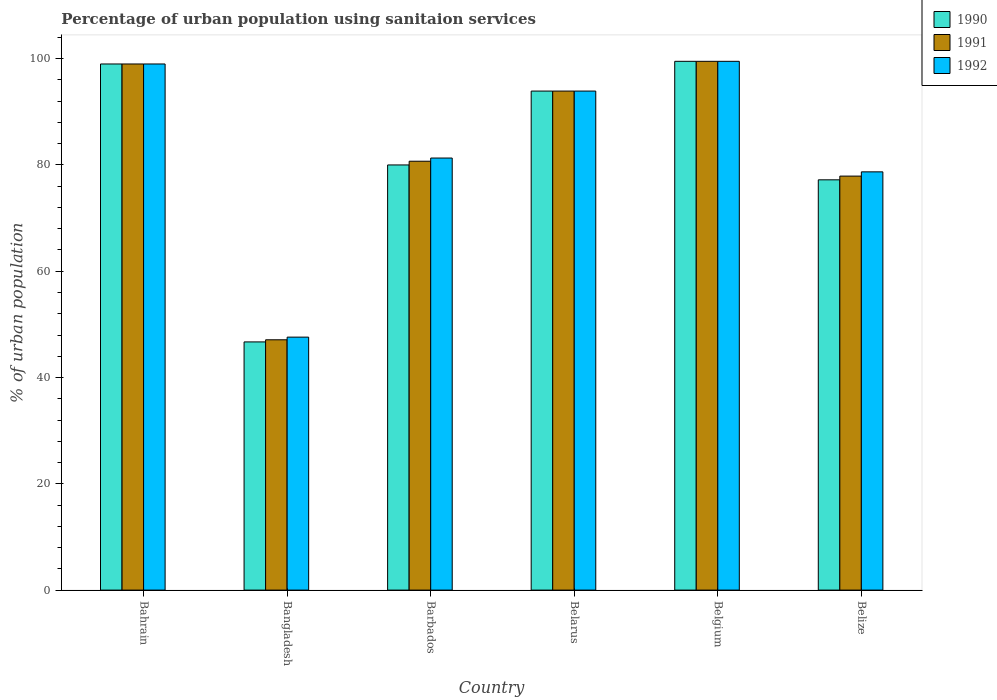How many different coloured bars are there?
Your response must be concise. 3. How many groups of bars are there?
Make the answer very short. 6. How many bars are there on the 6th tick from the right?
Your answer should be compact. 3. In how many cases, is the number of bars for a given country not equal to the number of legend labels?
Offer a very short reply. 0. What is the percentage of urban population using sanitaion services in 1990 in Belarus?
Keep it short and to the point. 93.9. Across all countries, what is the maximum percentage of urban population using sanitaion services in 1990?
Offer a very short reply. 99.5. Across all countries, what is the minimum percentage of urban population using sanitaion services in 1992?
Your response must be concise. 47.6. What is the total percentage of urban population using sanitaion services in 1991 in the graph?
Provide a short and direct response. 498.1. What is the difference between the percentage of urban population using sanitaion services in 1990 in Bahrain and that in Bangladesh?
Make the answer very short. 52.3. What is the difference between the percentage of urban population using sanitaion services in 1991 in Bangladesh and the percentage of urban population using sanitaion services in 1990 in Bahrain?
Provide a short and direct response. -51.9. What is the average percentage of urban population using sanitaion services in 1990 per country?
Offer a terse response. 82.72. What is the difference between the percentage of urban population using sanitaion services of/in 1990 and percentage of urban population using sanitaion services of/in 1991 in Bahrain?
Offer a terse response. 0. What is the ratio of the percentage of urban population using sanitaion services in 1992 in Bangladesh to that in Barbados?
Offer a very short reply. 0.59. Is the difference between the percentage of urban population using sanitaion services in 1990 in Belarus and Belgium greater than the difference between the percentage of urban population using sanitaion services in 1991 in Belarus and Belgium?
Offer a very short reply. No. What is the difference between the highest and the second highest percentage of urban population using sanitaion services in 1992?
Keep it short and to the point. -0.5. What is the difference between the highest and the lowest percentage of urban population using sanitaion services in 1990?
Make the answer very short. 52.8. Is the sum of the percentage of urban population using sanitaion services in 1991 in Barbados and Belarus greater than the maximum percentage of urban population using sanitaion services in 1990 across all countries?
Make the answer very short. Yes. What does the 3rd bar from the left in Belize represents?
Give a very brief answer. 1992. Is it the case that in every country, the sum of the percentage of urban population using sanitaion services in 1991 and percentage of urban population using sanitaion services in 1990 is greater than the percentage of urban population using sanitaion services in 1992?
Give a very brief answer. Yes. How many countries are there in the graph?
Offer a terse response. 6. What is the difference between two consecutive major ticks on the Y-axis?
Provide a short and direct response. 20. Are the values on the major ticks of Y-axis written in scientific E-notation?
Keep it short and to the point. No. Does the graph contain grids?
Give a very brief answer. No. How many legend labels are there?
Ensure brevity in your answer.  3. What is the title of the graph?
Provide a succinct answer. Percentage of urban population using sanitaion services. Does "2002" appear as one of the legend labels in the graph?
Keep it short and to the point. No. What is the label or title of the X-axis?
Provide a succinct answer. Country. What is the label or title of the Y-axis?
Offer a very short reply. % of urban population. What is the % of urban population in 1992 in Bahrain?
Your answer should be very brief. 99. What is the % of urban population in 1990 in Bangladesh?
Offer a terse response. 46.7. What is the % of urban population of 1991 in Bangladesh?
Provide a short and direct response. 47.1. What is the % of urban population of 1992 in Bangladesh?
Offer a terse response. 47.6. What is the % of urban population in 1991 in Barbados?
Your answer should be very brief. 80.7. What is the % of urban population in 1992 in Barbados?
Give a very brief answer. 81.3. What is the % of urban population of 1990 in Belarus?
Give a very brief answer. 93.9. What is the % of urban population of 1991 in Belarus?
Your answer should be compact. 93.9. What is the % of urban population of 1992 in Belarus?
Your response must be concise. 93.9. What is the % of urban population of 1990 in Belgium?
Your answer should be very brief. 99.5. What is the % of urban population of 1991 in Belgium?
Ensure brevity in your answer.  99.5. What is the % of urban population in 1992 in Belgium?
Provide a short and direct response. 99.5. What is the % of urban population in 1990 in Belize?
Provide a succinct answer. 77.2. What is the % of urban population of 1991 in Belize?
Your response must be concise. 77.9. What is the % of urban population in 1992 in Belize?
Offer a terse response. 78.7. Across all countries, what is the maximum % of urban population of 1990?
Your answer should be compact. 99.5. Across all countries, what is the maximum % of urban population of 1991?
Your answer should be very brief. 99.5. Across all countries, what is the maximum % of urban population in 1992?
Provide a succinct answer. 99.5. Across all countries, what is the minimum % of urban population in 1990?
Offer a very short reply. 46.7. Across all countries, what is the minimum % of urban population in 1991?
Provide a succinct answer. 47.1. Across all countries, what is the minimum % of urban population of 1992?
Keep it short and to the point. 47.6. What is the total % of urban population in 1990 in the graph?
Offer a terse response. 496.3. What is the total % of urban population of 1991 in the graph?
Provide a succinct answer. 498.1. What is the difference between the % of urban population of 1990 in Bahrain and that in Bangladesh?
Make the answer very short. 52.3. What is the difference between the % of urban population of 1991 in Bahrain and that in Bangladesh?
Make the answer very short. 51.9. What is the difference between the % of urban population in 1992 in Bahrain and that in Bangladesh?
Provide a short and direct response. 51.4. What is the difference between the % of urban population in 1990 in Bahrain and that in Barbados?
Your response must be concise. 19. What is the difference between the % of urban population in 1991 in Bahrain and that in Barbados?
Provide a succinct answer. 18.3. What is the difference between the % of urban population in 1991 in Bahrain and that in Belarus?
Offer a very short reply. 5.1. What is the difference between the % of urban population of 1991 in Bahrain and that in Belgium?
Your response must be concise. -0.5. What is the difference between the % of urban population of 1990 in Bahrain and that in Belize?
Offer a very short reply. 21.8. What is the difference between the % of urban population of 1991 in Bahrain and that in Belize?
Make the answer very short. 21.1. What is the difference between the % of urban population in 1992 in Bahrain and that in Belize?
Give a very brief answer. 20.3. What is the difference between the % of urban population of 1990 in Bangladesh and that in Barbados?
Your answer should be compact. -33.3. What is the difference between the % of urban population of 1991 in Bangladesh and that in Barbados?
Give a very brief answer. -33.6. What is the difference between the % of urban population of 1992 in Bangladesh and that in Barbados?
Your response must be concise. -33.7. What is the difference between the % of urban population in 1990 in Bangladesh and that in Belarus?
Provide a succinct answer. -47.2. What is the difference between the % of urban population of 1991 in Bangladesh and that in Belarus?
Offer a very short reply. -46.8. What is the difference between the % of urban population of 1992 in Bangladesh and that in Belarus?
Your answer should be very brief. -46.3. What is the difference between the % of urban population in 1990 in Bangladesh and that in Belgium?
Your response must be concise. -52.8. What is the difference between the % of urban population of 1991 in Bangladesh and that in Belgium?
Provide a short and direct response. -52.4. What is the difference between the % of urban population in 1992 in Bangladesh and that in Belgium?
Your answer should be compact. -51.9. What is the difference between the % of urban population of 1990 in Bangladesh and that in Belize?
Provide a short and direct response. -30.5. What is the difference between the % of urban population in 1991 in Bangladesh and that in Belize?
Offer a terse response. -30.8. What is the difference between the % of urban population in 1992 in Bangladesh and that in Belize?
Give a very brief answer. -31.1. What is the difference between the % of urban population of 1990 in Barbados and that in Belarus?
Give a very brief answer. -13.9. What is the difference between the % of urban population of 1990 in Barbados and that in Belgium?
Provide a short and direct response. -19.5. What is the difference between the % of urban population in 1991 in Barbados and that in Belgium?
Keep it short and to the point. -18.8. What is the difference between the % of urban population in 1992 in Barbados and that in Belgium?
Your answer should be very brief. -18.2. What is the difference between the % of urban population in 1990 in Barbados and that in Belize?
Your answer should be compact. 2.8. What is the difference between the % of urban population in 1992 in Barbados and that in Belize?
Give a very brief answer. 2.6. What is the difference between the % of urban population in 1990 in Belgium and that in Belize?
Provide a succinct answer. 22.3. What is the difference between the % of urban population of 1991 in Belgium and that in Belize?
Offer a terse response. 21.6. What is the difference between the % of urban population of 1992 in Belgium and that in Belize?
Ensure brevity in your answer.  20.8. What is the difference between the % of urban population of 1990 in Bahrain and the % of urban population of 1991 in Bangladesh?
Keep it short and to the point. 51.9. What is the difference between the % of urban population of 1990 in Bahrain and the % of urban population of 1992 in Bangladesh?
Keep it short and to the point. 51.4. What is the difference between the % of urban population in 1991 in Bahrain and the % of urban population in 1992 in Bangladesh?
Make the answer very short. 51.4. What is the difference between the % of urban population of 1991 in Bahrain and the % of urban population of 1992 in Barbados?
Provide a short and direct response. 17.7. What is the difference between the % of urban population in 1990 in Bahrain and the % of urban population in 1991 in Belarus?
Ensure brevity in your answer.  5.1. What is the difference between the % of urban population in 1990 in Bahrain and the % of urban population in 1992 in Belarus?
Ensure brevity in your answer.  5.1. What is the difference between the % of urban population in 1990 in Bahrain and the % of urban population in 1991 in Belgium?
Provide a short and direct response. -0.5. What is the difference between the % of urban population of 1990 in Bahrain and the % of urban population of 1992 in Belgium?
Offer a terse response. -0.5. What is the difference between the % of urban population in 1991 in Bahrain and the % of urban population in 1992 in Belgium?
Ensure brevity in your answer.  -0.5. What is the difference between the % of urban population of 1990 in Bahrain and the % of urban population of 1991 in Belize?
Provide a short and direct response. 21.1. What is the difference between the % of urban population of 1990 in Bahrain and the % of urban population of 1992 in Belize?
Ensure brevity in your answer.  20.3. What is the difference between the % of urban population in 1991 in Bahrain and the % of urban population in 1992 in Belize?
Make the answer very short. 20.3. What is the difference between the % of urban population in 1990 in Bangladesh and the % of urban population in 1991 in Barbados?
Ensure brevity in your answer.  -34. What is the difference between the % of urban population of 1990 in Bangladesh and the % of urban population of 1992 in Barbados?
Give a very brief answer. -34.6. What is the difference between the % of urban population in 1991 in Bangladesh and the % of urban population in 1992 in Barbados?
Make the answer very short. -34.2. What is the difference between the % of urban population of 1990 in Bangladesh and the % of urban population of 1991 in Belarus?
Your answer should be compact. -47.2. What is the difference between the % of urban population in 1990 in Bangladesh and the % of urban population in 1992 in Belarus?
Ensure brevity in your answer.  -47.2. What is the difference between the % of urban population in 1991 in Bangladesh and the % of urban population in 1992 in Belarus?
Offer a terse response. -46.8. What is the difference between the % of urban population of 1990 in Bangladesh and the % of urban population of 1991 in Belgium?
Your response must be concise. -52.8. What is the difference between the % of urban population of 1990 in Bangladesh and the % of urban population of 1992 in Belgium?
Your answer should be very brief. -52.8. What is the difference between the % of urban population of 1991 in Bangladesh and the % of urban population of 1992 in Belgium?
Provide a short and direct response. -52.4. What is the difference between the % of urban population of 1990 in Bangladesh and the % of urban population of 1991 in Belize?
Your answer should be very brief. -31.2. What is the difference between the % of urban population of 1990 in Bangladesh and the % of urban population of 1992 in Belize?
Offer a terse response. -32. What is the difference between the % of urban population in 1991 in Bangladesh and the % of urban population in 1992 in Belize?
Provide a short and direct response. -31.6. What is the difference between the % of urban population of 1991 in Barbados and the % of urban population of 1992 in Belarus?
Provide a succinct answer. -13.2. What is the difference between the % of urban population of 1990 in Barbados and the % of urban population of 1991 in Belgium?
Offer a terse response. -19.5. What is the difference between the % of urban population of 1990 in Barbados and the % of urban population of 1992 in Belgium?
Your answer should be compact. -19.5. What is the difference between the % of urban population of 1991 in Barbados and the % of urban population of 1992 in Belgium?
Make the answer very short. -18.8. What is the difference between the % of urban population in 1990 in Belarus and the % of urban population in 1992 in Belgium?
Provide a succinct answer. -5.6. What is the difference between the % of urban population in 1991 in Belarus and the % of urban population in 1992 in Belgium?
Keep it short and to the point. -5.6. What is the difference between the % of urban population of 1990 in Belgium and the % of urban population of 1991 in Belize?
Your answer should be very brief. 21.6. What is the difference between the % of urban population of 1990 in Belgium and the % of urban population of 1992 in Belize?
Your answer should be compact. 20.8. What is the difference between the % of urban population in 1991 in Belgium and the % of urban population in 1992 in Belize?
Offer a terse response. 20.8. What is the average % of urban population in 1990 per country?
Your answer should be very brief. 82.72. What is the average % of urban population of 1991 per country?
Offer a very short reply. 83.02. What is the average % of urban population of 1992 per country?
Provide a short and direct response. 83.33. What is the difference between the % of urban population in 1990 and % of urban population in 1992 in Bahrain?
Keep it short and to the point. 0. What is the difference between the % of urban population of 1991 and % of urban population of 1992 in Bahrain?
Make the answer very short. 0. What is the difference between the % of urban population of 1990 and % of urban population of 1991 in Bangladesh?
Ensure brevity in your answer.  -0.4. What is the difference between the % of urban population in 1990 and % of urban population in 1992 in Bangladesh?
Ensure brevity in your answer.  -0.9. What is the difference between the % of urban population of 1991 and % of urban population of 1992 in Bangladesh?
Offer a terse response. -0.5. What is the difference between the % of urban population of 1991 and % of urban population of 1992 in Barbados?
Offer a terse response. -0.6. What is the difference between the % of urban population in 1990 and % of urban population in 1992 in Belarus?
Keep it short and to the point. 0. What is the difference between the % of urban population in 1991 and % of urban population in 1992 in Belarus?
Make the answer very short. 0. What is the difference between the % of urban population in 1990 and % of urban population in 1991 in Belgium?
Your answer should be very brief. 0. What is the difference between the % of urban population in 1990 and % of urban population in 1992 in Belgium?
Your answer should be compact. 0. What is the difference between the % of urban population of 1991 and % of urban population of 1992 in Belgium?
Offer a terse response. 0. What is the ratio of the % of urban population in 1990 in Bahrain to that in Bangladesh?
Your response must be concise. 2.12. What is the ratio of the % of urban population of 1991 in Bahrain to that in Bangladesh?
Keep it short and to the point. 2.1. What is the ratio of the % of urban population in 1992 in Bahrain to that in Bangladesh?
Offer a very short reply. 2.08. What is the ratio of the % of urban population in 1990 in Bahrain to that in Barbados?
Your answer should be very brief. 1.24. What is the ratio of the % of urban population in 1991 in Bahrain to that in Barbados?
Ensure brevity in your answer.  1.23. What is the ratio of the % of urban population of 1992 in Bahrain to that in Barbados?
Provide a short and direct response. 1.22. What is the ratio of the % of urban population of 1990 in Bahrain to that in Belarus?
Your answer should be very brief. 1.05. What is the ratio of the % of urban population in 1991 in Bahrain to that in Belarus?
Keep it short and to the point. 1.05. What is the ratio of the % of urban population in 1992 in Bahrain to that in Belarus?
Your answer should be very brief. 1.05. What is the ratio of the % of urban population of 1991 in Bahrain to that in Belgium?
Your response must be concise. 0.99. What is the ratio of the % of urban population of 1990 in Bahrain to that in Belize?
Give a very brief answer. 1.28. What is the ratio of the % of urban population in 1991 in Bahrain to that in Belize?
Give a very brief answer. 1.27. What is the ratio of the % of urban population of 1992 in Bahrain to that in Belize?
Offer a terse response. 1.26. What is the ratio of the % of urban population in 1990 in Bangladesh to that in Barbados?
Provide a short and direct response. 0.58. What is the ratio of the % of urban population in 1991 in Bangladesh to that in Barbados?
Your answer should be compact. 0.58. What is the ratio of the % of urban population of 1992 in Bangladesh to that in Barbados?
Provide a succinct answer. 0.59. What is the ratio of the % of urban population in 1990 in Bangladesh to that in Belarus?
Give a very brief answer. 0.5. What is the ratio of the % of urban population in 1991 in Bangladesh to that in Belarus?
Make the answer very short. 0.5. What is the ratio of the % of urban population of 1992 in Bangladesh to that in Belarus?
Offer a terse response. 0.51. What is the ratio of the % of urban population of 1990 in Bangladesh to that in Belgium?
Your response must be concise. 0.47. What is the ratio of the % of urban population in 1991 in Bangladesh to that in Belgium?
Your answer should be very brief. 0.47. What is the ratio of the % of urban population in 1992 in Bangladesh to that in Belgium?
Your answer should be very brief. 0.48. What is the ratio of the % of urban population in 1990 in Bangladesh to that in Belize?
Make the answer very short. 0.6. What is the ratio of the % of urban population in 1991 in Bangladesh to that in Belize?
Provide a succinct answer. 0.6. What is the ratio of the % of urban population in 1992 in Bangladesh to that in Belize?
Make the answer very short. 0.6. What is the ratio of the % of urban population in 1990 in Barbados to that in Belarus?
Keep it short and to the point. 0.85. What is the ratio of the % of urban population of 1991 in Barbados to that in Belarus?
Your response must be concise. 0.86. What is the ratio of the % of urban population of 1992 in Barbados to that in Belarus?
Your response must be concise. 0.87. What is the ratio of the % of urban population in 1990 in Barbados to that in Belgium?
Ensure brevity in your answer.  0.8. What is the ratio of the % of urban population in 1991 in Barbados to that in Belgium?
Keep it short and to the point. 0.81. What is the ratio of the % of urban population in 1992 in Barbados to that in Belgium?
Make the answer very short. 0.82. What is the ratio of the % of urban population in 1990 in Barbados to that in Belize?
Keep it short and to the point. 1.04. What is the ratio of the % of urban population in 1991 in Barbados to that in Belize?
Keep it short and to the point. 1.04. What is the ratio of the % of urban population of 1992 in Barbados to that in Belize?
Your answer should be compact. 1.03. What is the ratio of the % of urban population of 1990 in Belarus to that in Belgium?
Your answer should be very brief. 0.94. What is the ratio of the % of urban population in 1991 in Belarus to that in Belgium?
Offer a terse response. 0.94. What is the ratio of the % of urban population of 1992 in Belarus to that in Belgium?
Make the answer very short. 0.94. What is the ratio of the % of urban population of 1990 in Belarus to that in Belize?
Keep it short and to the point. 1.22. What is the ratio of the % of urban population in 1991 in Belarus to that in Belize?
Give a very brief answer. 1.21. What is the ratio of the % of urban population in 1992 in Belarus to that in Belize?
Offer a terse response. 1.19. What is the ratio of the % of urban population in 1990 in Belgium to that in Belize?
Your response must be concise. 1.29. What is the ratio of the % of urban population of 1991 in Belgium to that in Belize?
Give a very brief answer. 1.28. What is the ratio of the % of urban population in 1992 in Belgium to that in Belize?
Keep it short and to the point. 1.26. What is the difference between the highest and the second highest % of urban population of 1992?
Provide a succinct answer. 0.5. What is the difference between the highest and the lowest % of urban population in 1990?
Your answer should be very brief. 52.8. What is the difference between the highest and the lowest % of urban population in 1991?
Provide a short and direct response. 52.4. What is the difference between the highest and the lowest % of urban population of 1992?
Provide a short and direct response. 51.9. 